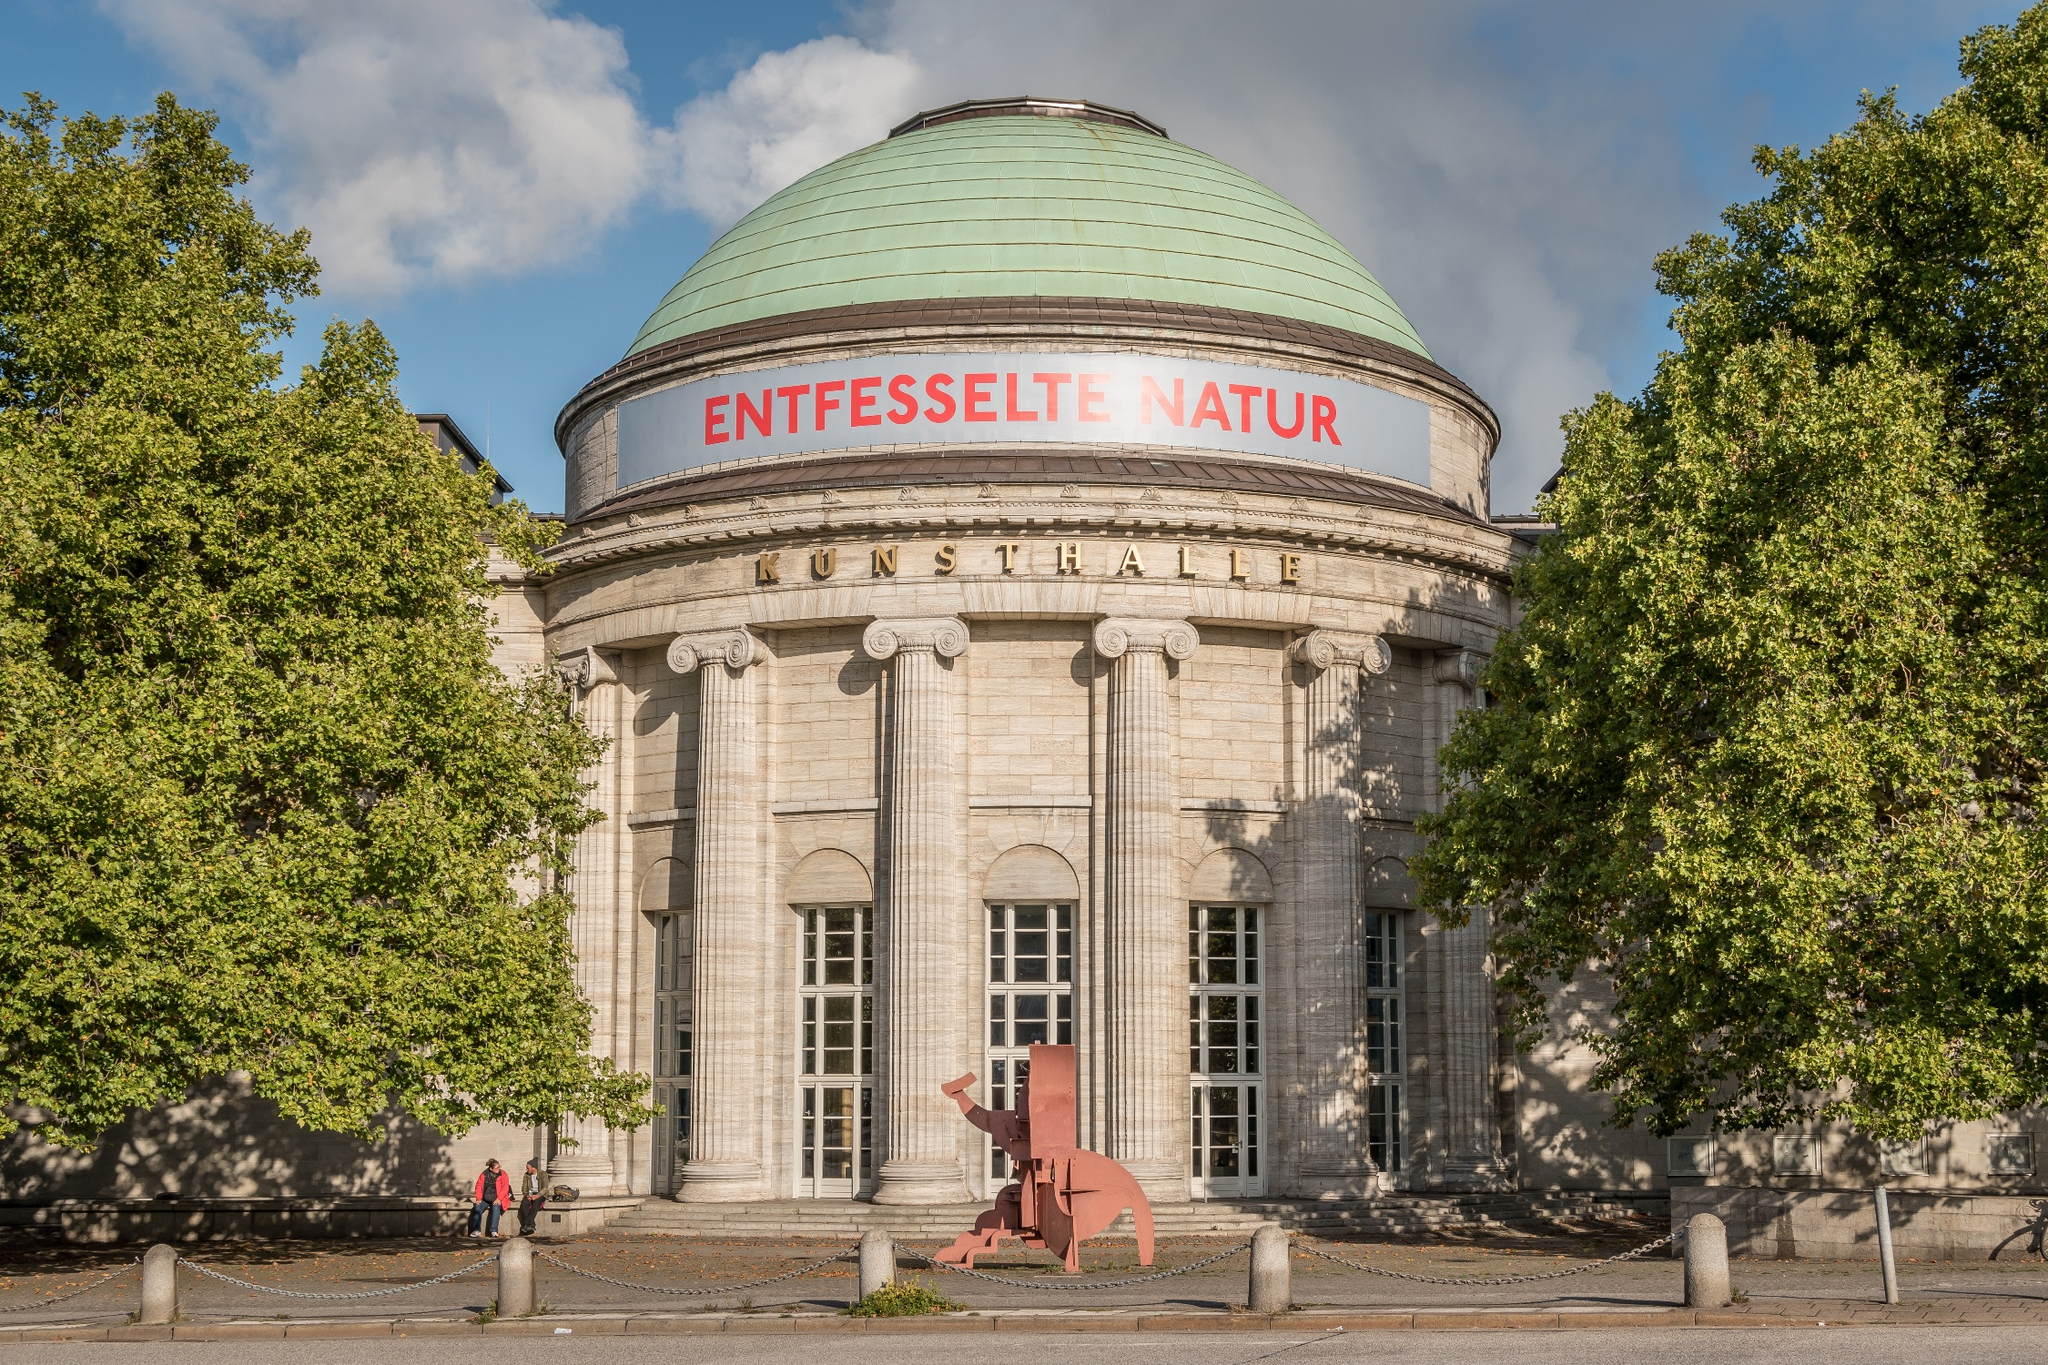What is written above the entrance? Above the entrance of the building, you can see the words 'ENTFESSELTE NATUR' which translates to 'Unleashed Nature' in English, along with 'KUNSTHALLE', indicating that this is the Kunsthalle Hamburg, an esteemed art museum. What might 'Unleashed Nature' refer to in the context of an art museum? 'Unleashed Nature' could refer to a special exhibition or a broader thematic focus within the art museum. It might highlight artworks that explore the wild, untamed aspects of nature, showcasing the raw beauty and profound power of natural landscapes and phenomena. This theme could be represented through various media, including paintings, sculptures, installations, and photography, each interpreting the essence of nature's forces and the intricate relationship between humanity and the natural world. 